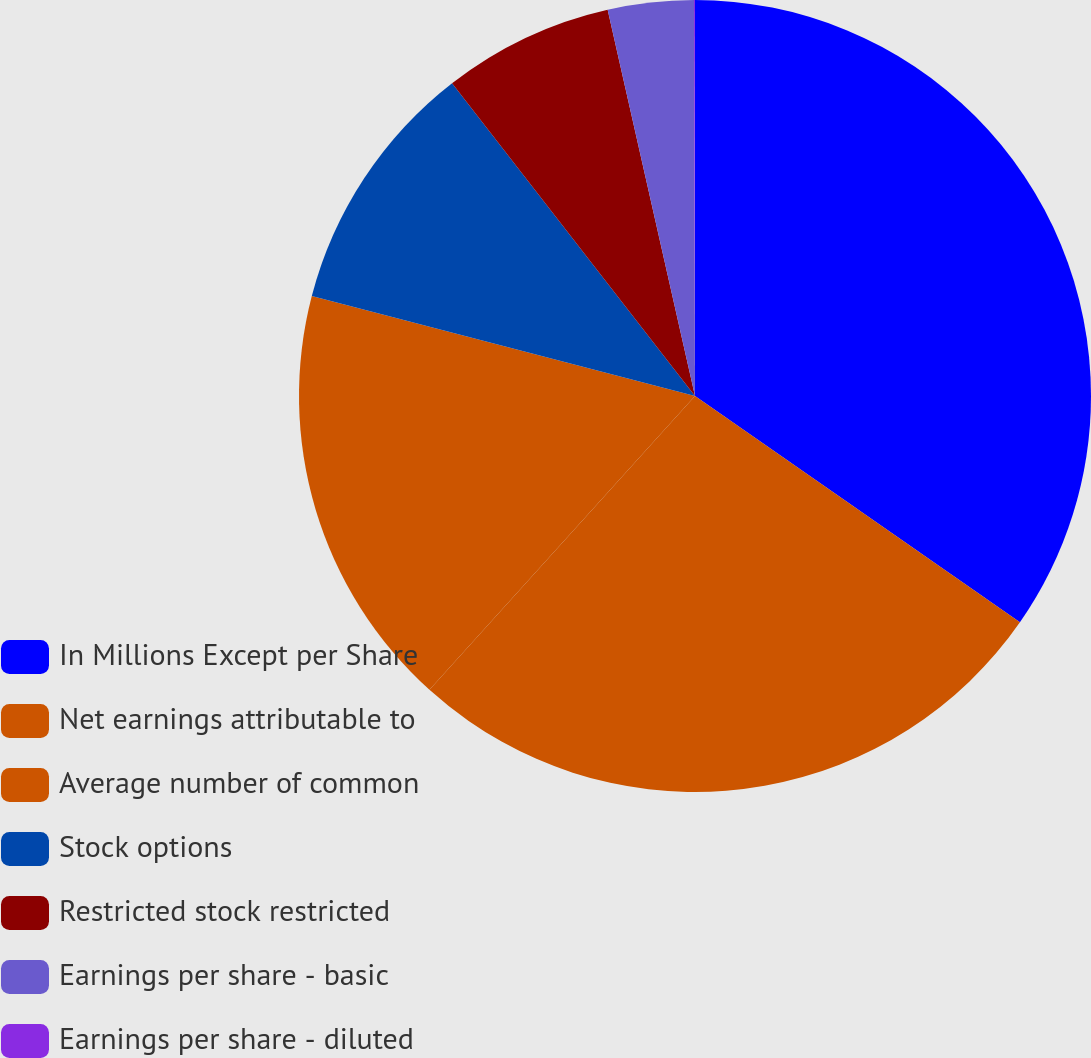Convert chart. <chart><loc_0><loc_0><loc_500><loc_500><pie_chart><fcel>In Millions Except per Share<fcel>Net earnings attributable to<fcel>Average number of common<fcel>Stock options<fcel>Restricted stock restricted<fcel>Earnings per share - basic<fcel>Earnings per share - diluted<nl><fcel>34.68%<fcel>27.01%<fcel>17.36%<fcel>10.43%<fcel>6.97%<fcel>3.5%<fcel>0.04%<nl></chart> 